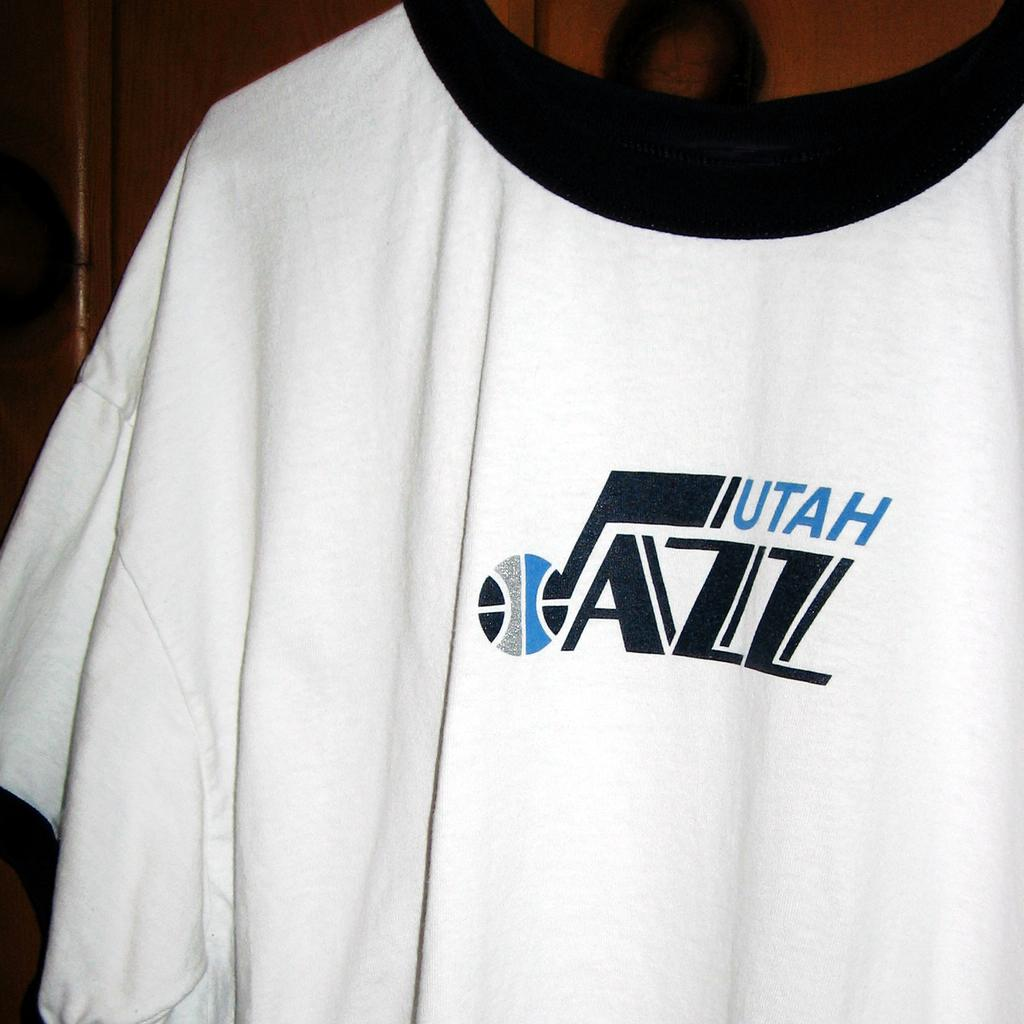<image>
Write a terse but informative summary of the picture. A white and black shirt that says Utah Jazz on it. 